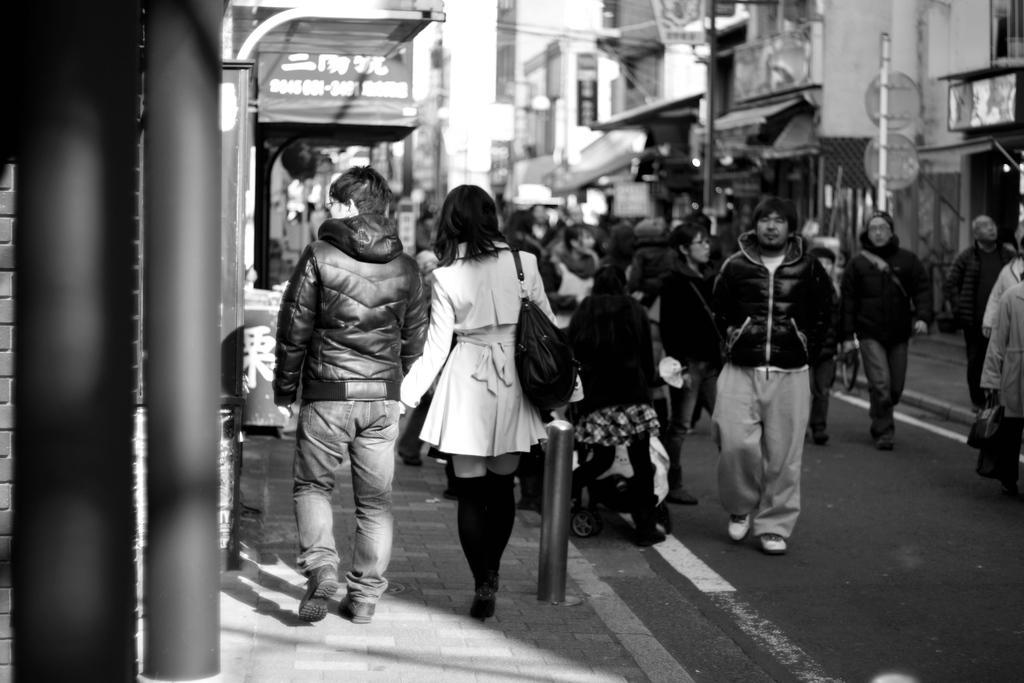How would you summarize this image in a sentence or two? In this image I can see many peoples walking on the road, and on the left I can see the poles , and there are other poles on the right side. 